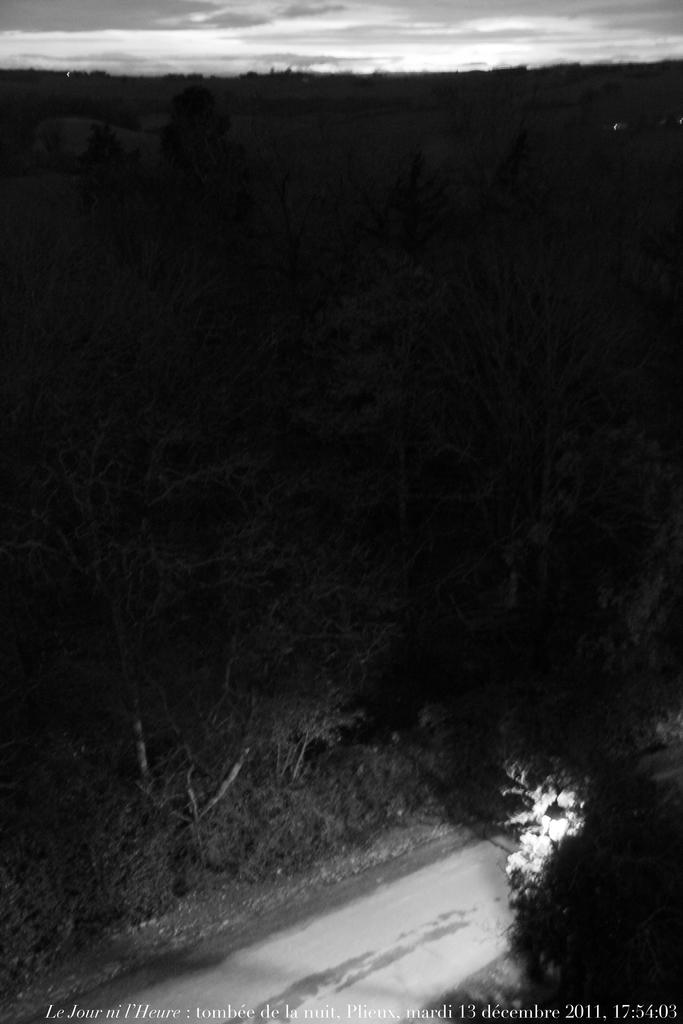What type of vegetation can be seen in the image? There are trees in the image. What type of man-made object is present in the image? There is a street lamp in the image. What is visible at the top of the image? The sky is visible at the top of the image. How would you describe the lighting in the image? The image appears to be slightly dark. Can you see a girl holding a gun in the image? There is no girl or gun present in the image. 